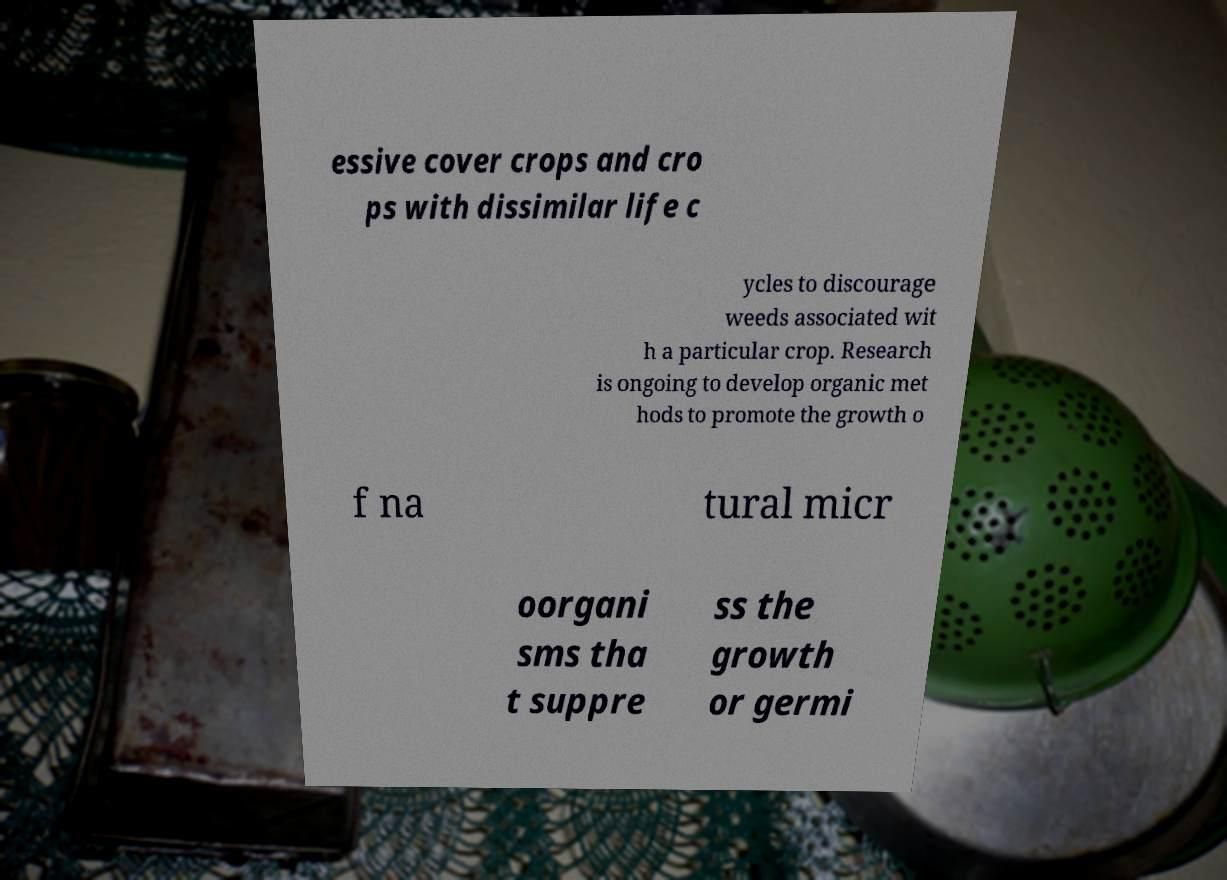Could you extract and type out the text from this image? essive cover crops and cro ps with dissimilar life c ycles to discourage weeds associated wit h a particular crop. Research is ongoing to develop organic met hods to promote the growth o f na tural micr oorgani sms tha t suppre ss the growth or germi 